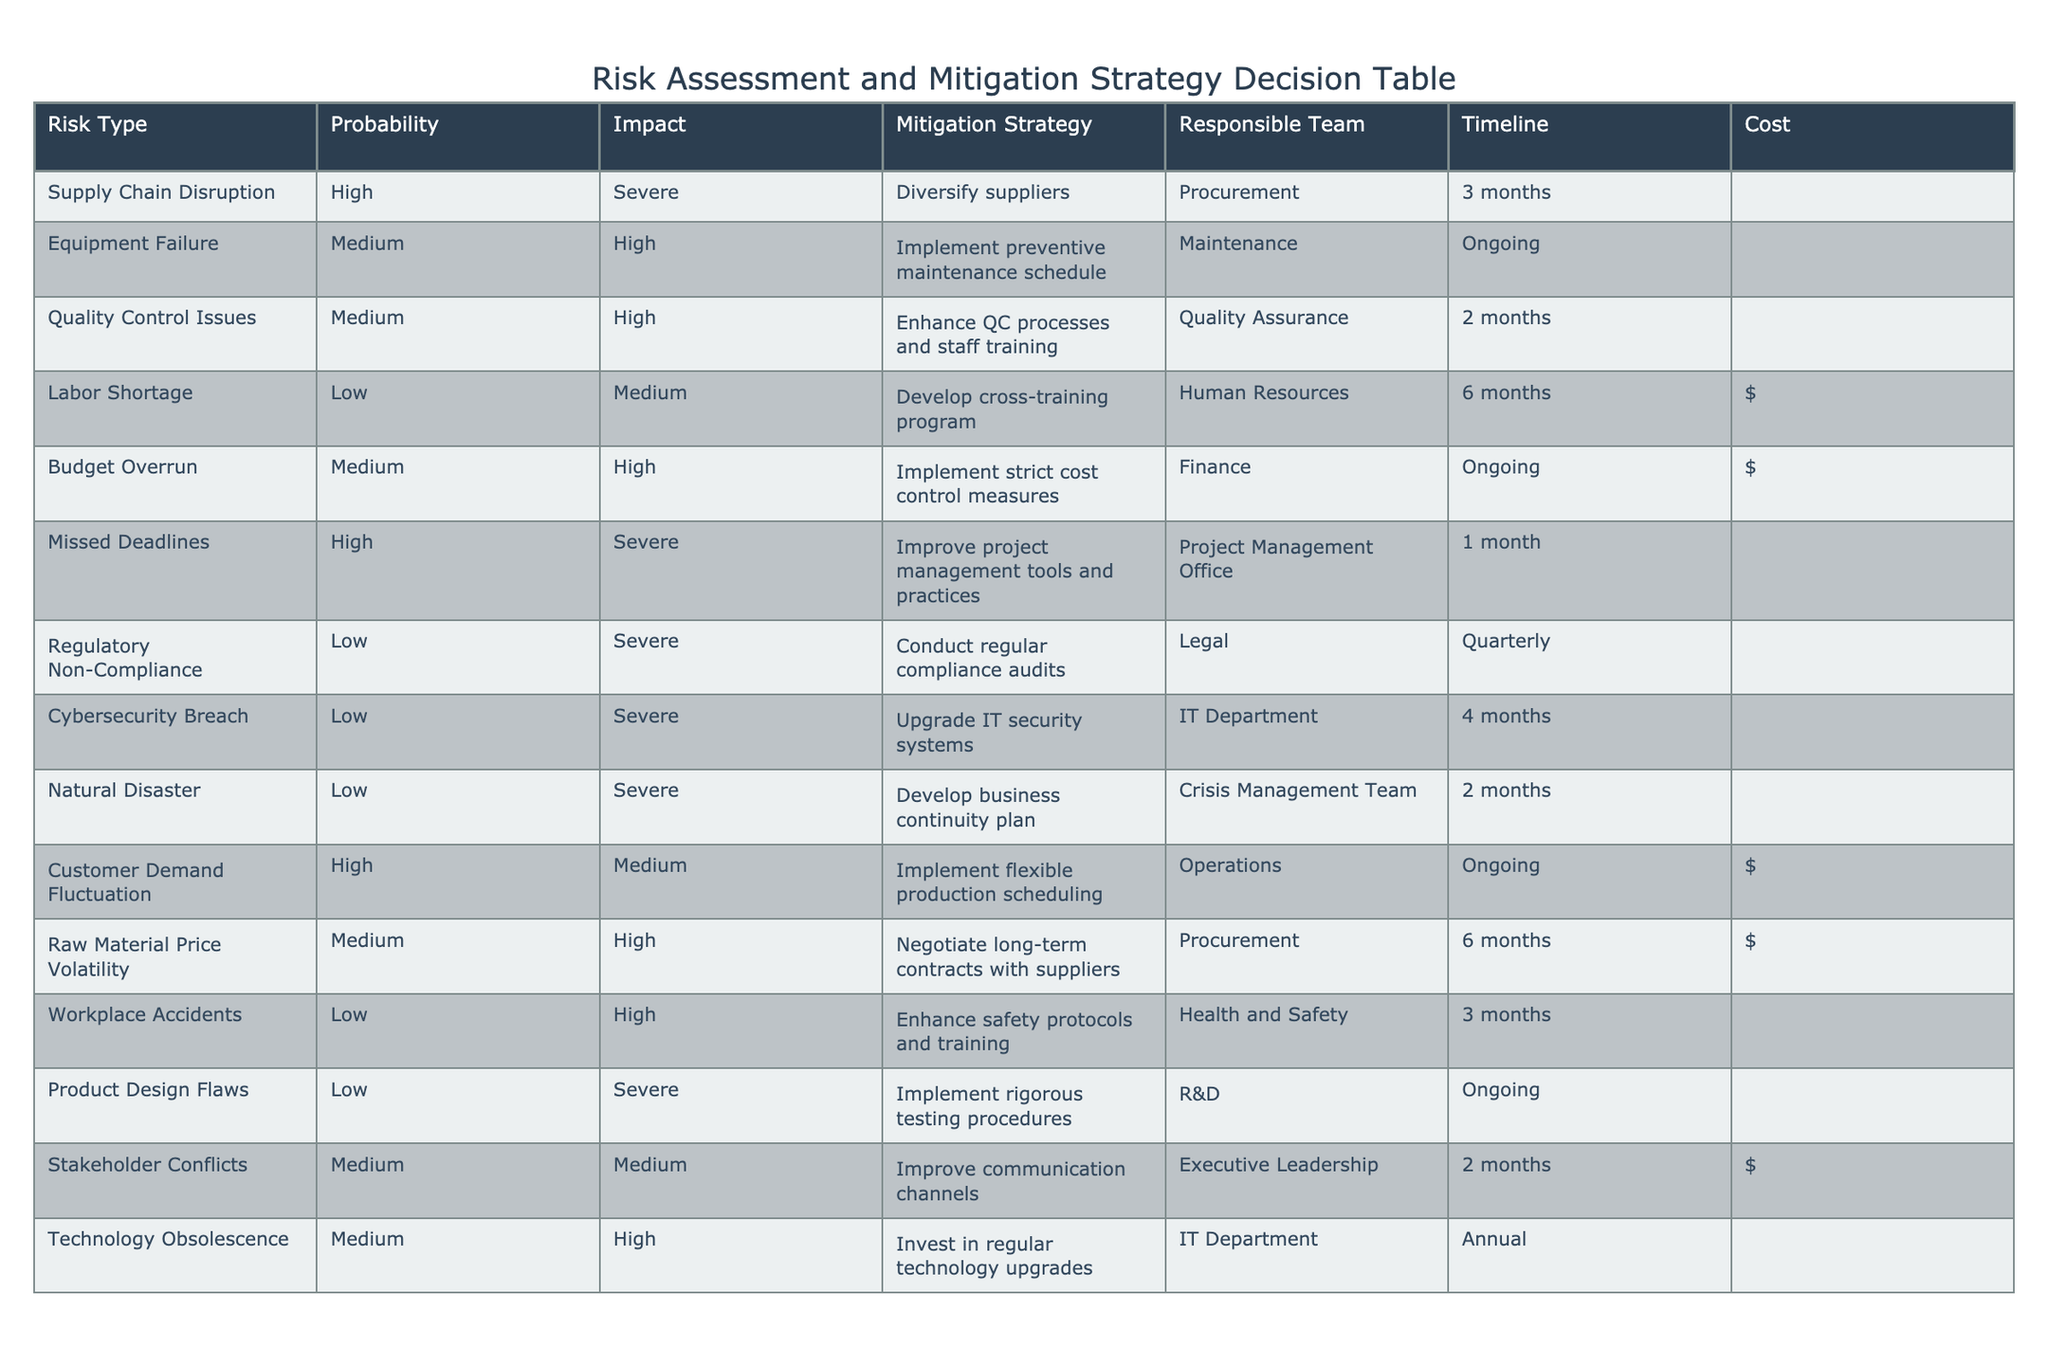What is the mitigation strategy for Supply Chain Disruption? The row corresponding to Supply Chain Disruption shows that the mitigation strategy is to diversify suppliers.
Answer: Diversify suppliers How many risks have a Medium probability? By reviewing the table, the risks with Medium probability are Equipment Failure, Quality Control Issues, Budget Overrun, Customer Demand Fluctuation, and Technology Obsolescence. Counting these gives a total of 5 risks.
Answer: 5 Is the responsible team for Labor Shortage from the Maintenance department? The table indicates that the responsible team for Labor Shortage is Human Resources, not the Maintenance department.
Answer: No What is the total cost of mitigation strategies that involve ongoing timelines? The risks with ongoing timelines are Budget Overrun, Product Design Flaws, and Labor Shortage. The costs associated with these are $, $$$, and $ respectively. Summing the costs (1 + 3 + 1) indicates the ongoing strategies overall are at a cost of 5 (where $ = 1 and $$$ = 3).
Answer: 5 Which risk type has the shortest timeline for mitigation? Among the risks listed, Missed Deadlines has the shortest timeline of 1 month, compared to others.
Answer: 1 month What is the average impact level for risks categorized as High? Referring to the risks with High impact (indicated as Severe or High), we have Missed Deadlines (Severe), Equipment Failure (High), and Quality Control Issues (High). Two are categorized as High and one as Severe. We can assign numerical values to impacts for averaging purposes: Severe = 2, High = 1. The average calculated is (2 + 1 + 1) / 3 = 4 / 3 = 1.33, which suggests the average impact level is biased towards the High end.
Answer: 1.33 Which risk has a responsible team from the IT department? The table indicates that the risks assigned to the IT Department are Cybersecurity Breach and Technology Obsolescence.
Answer: Cybersecurity Breach and Technology Obsolescence How many risks have a severe impact but low probability? The only risks with severe impact categorized as Low probability are Regulatory Non-Compliance, Cybersecurity Breach, and Natural Disaster. Therefore, counting these gives a total of 3 risks.
Answer: 3 Does enhancing safety protocols help mitigate Workplace Accidents? The mitigation strategy for Workplace Accidents indicates that enhancing safety protocols and training is aimed directly at preventing such accidents. Therefore, it is justified to say this strategy is indeed meant to mitigate the risks of Workplace Accidents.
Answer: Yes 